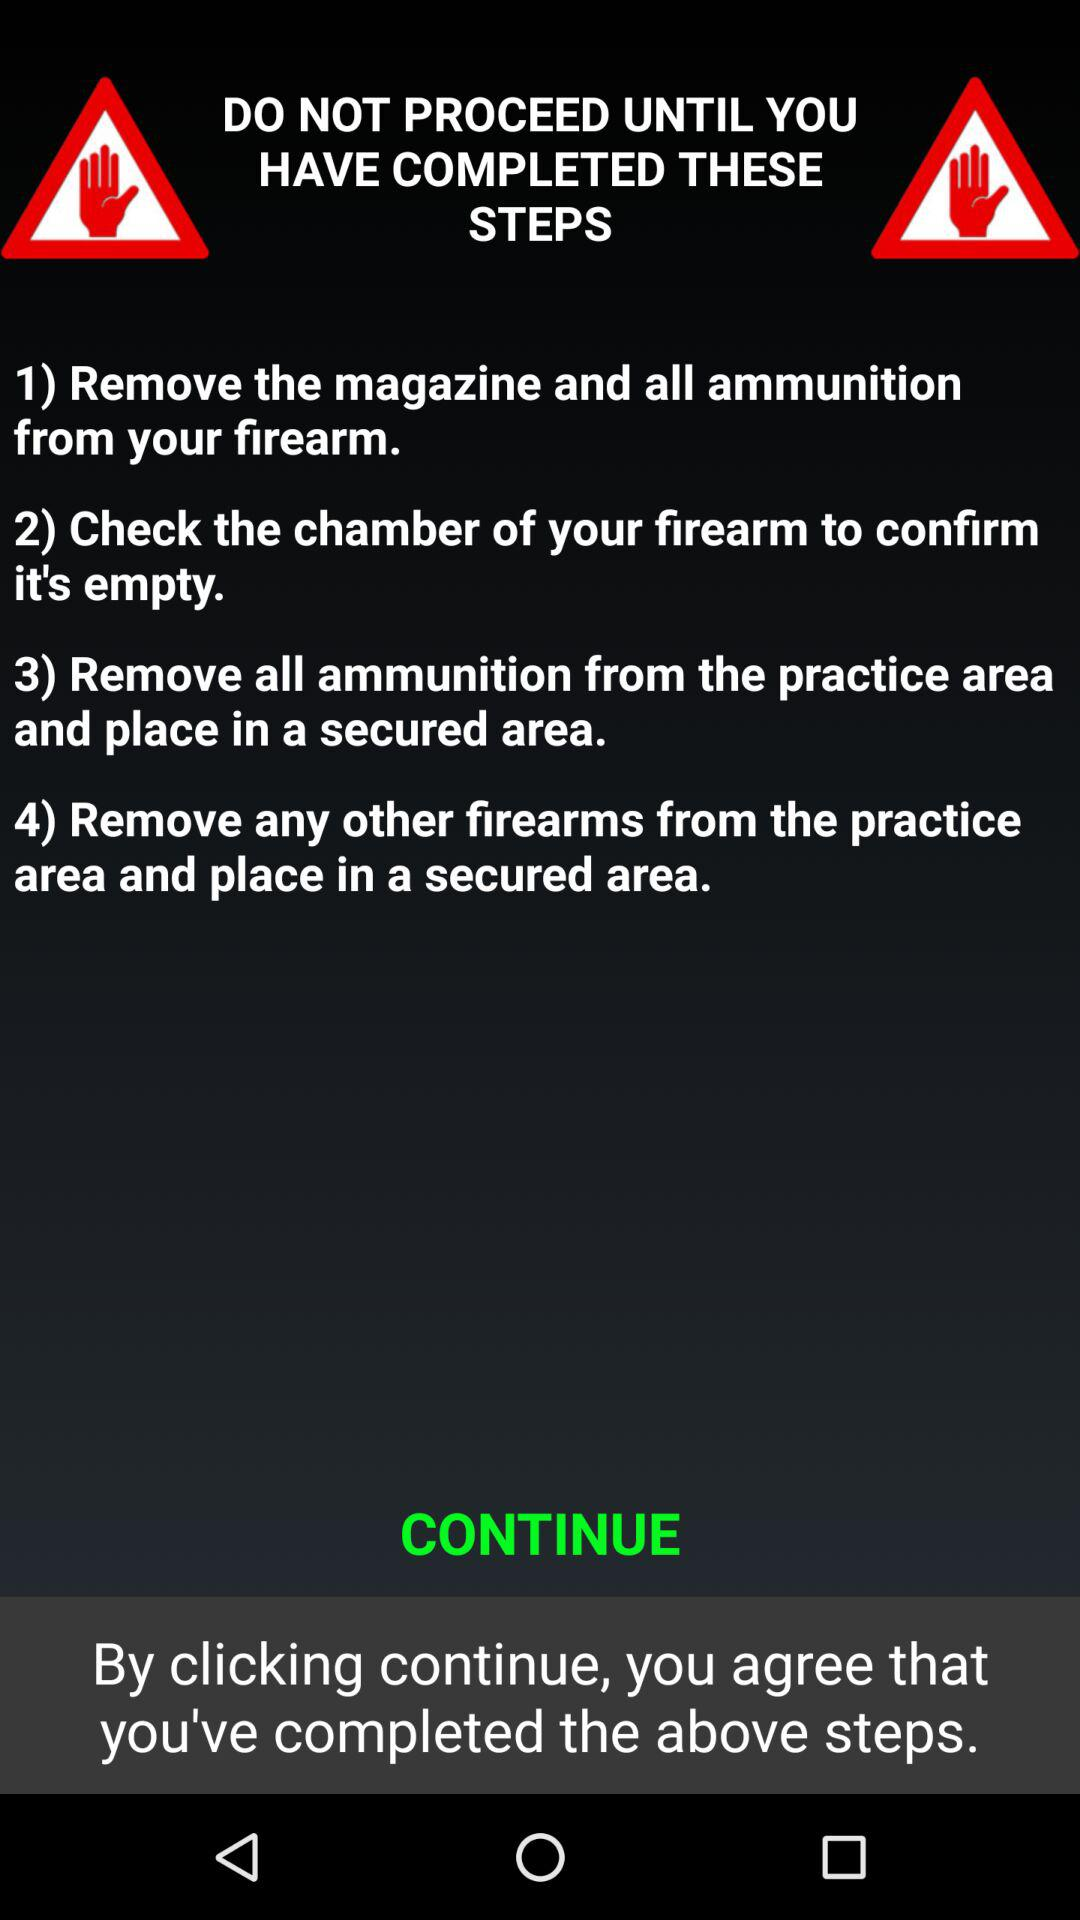How many steps are required to proceed?
Answer the question using a single word or phrase. 4 